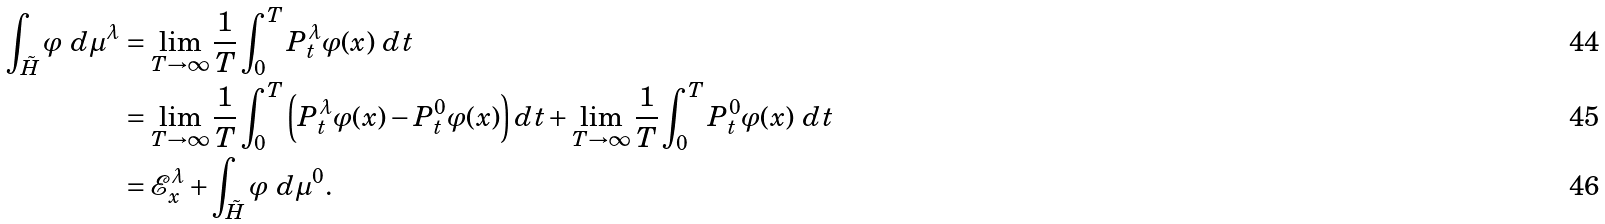<formula> <loc_0><loc_0><loc_500><loc_500>\int _ { \tilde { H } } \varphi \ d \mu ^ { \lambda } & = \lim _ { T \rightarrow \infty } \frac { 1 } { T } \int _ { 0 } ^ { T } P _ { t } ^ { \lambda } \varphi ( x ) \ d t \\ & = \lim _ { T \rightarrow \infty } \frac { 1 } { T } \int _ { 0 } ^ { T } \left ( P _ { t } ^ { \lambda } \varphi ( x ) - P _ { t } ^ { 0 } \varphi ( x ) \right ) d t + \lim _ { T \rightarrow \infty } \frac { 1 } { T } \int _ { 0 } ^ { T } P _ { t } ^ { 0 } \varphi ( x ) \ d t \\ & = \mathcal { E } _ { x } ^ { \lambda } + \int _ { \tilde { H } } \varphi \ d \mu ^ { 0 } .</formula> 